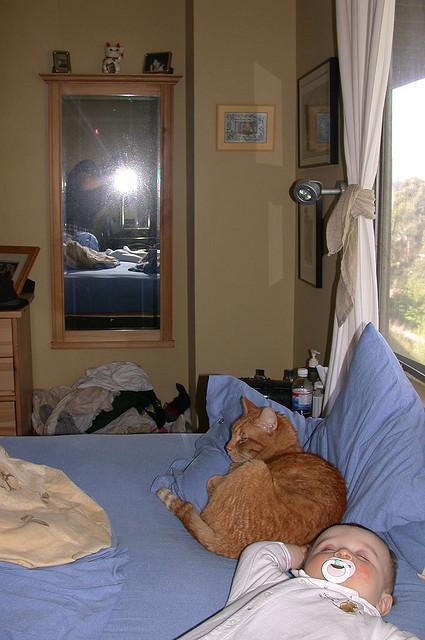How many people can be seen?
Give a very brief answer. 2. 